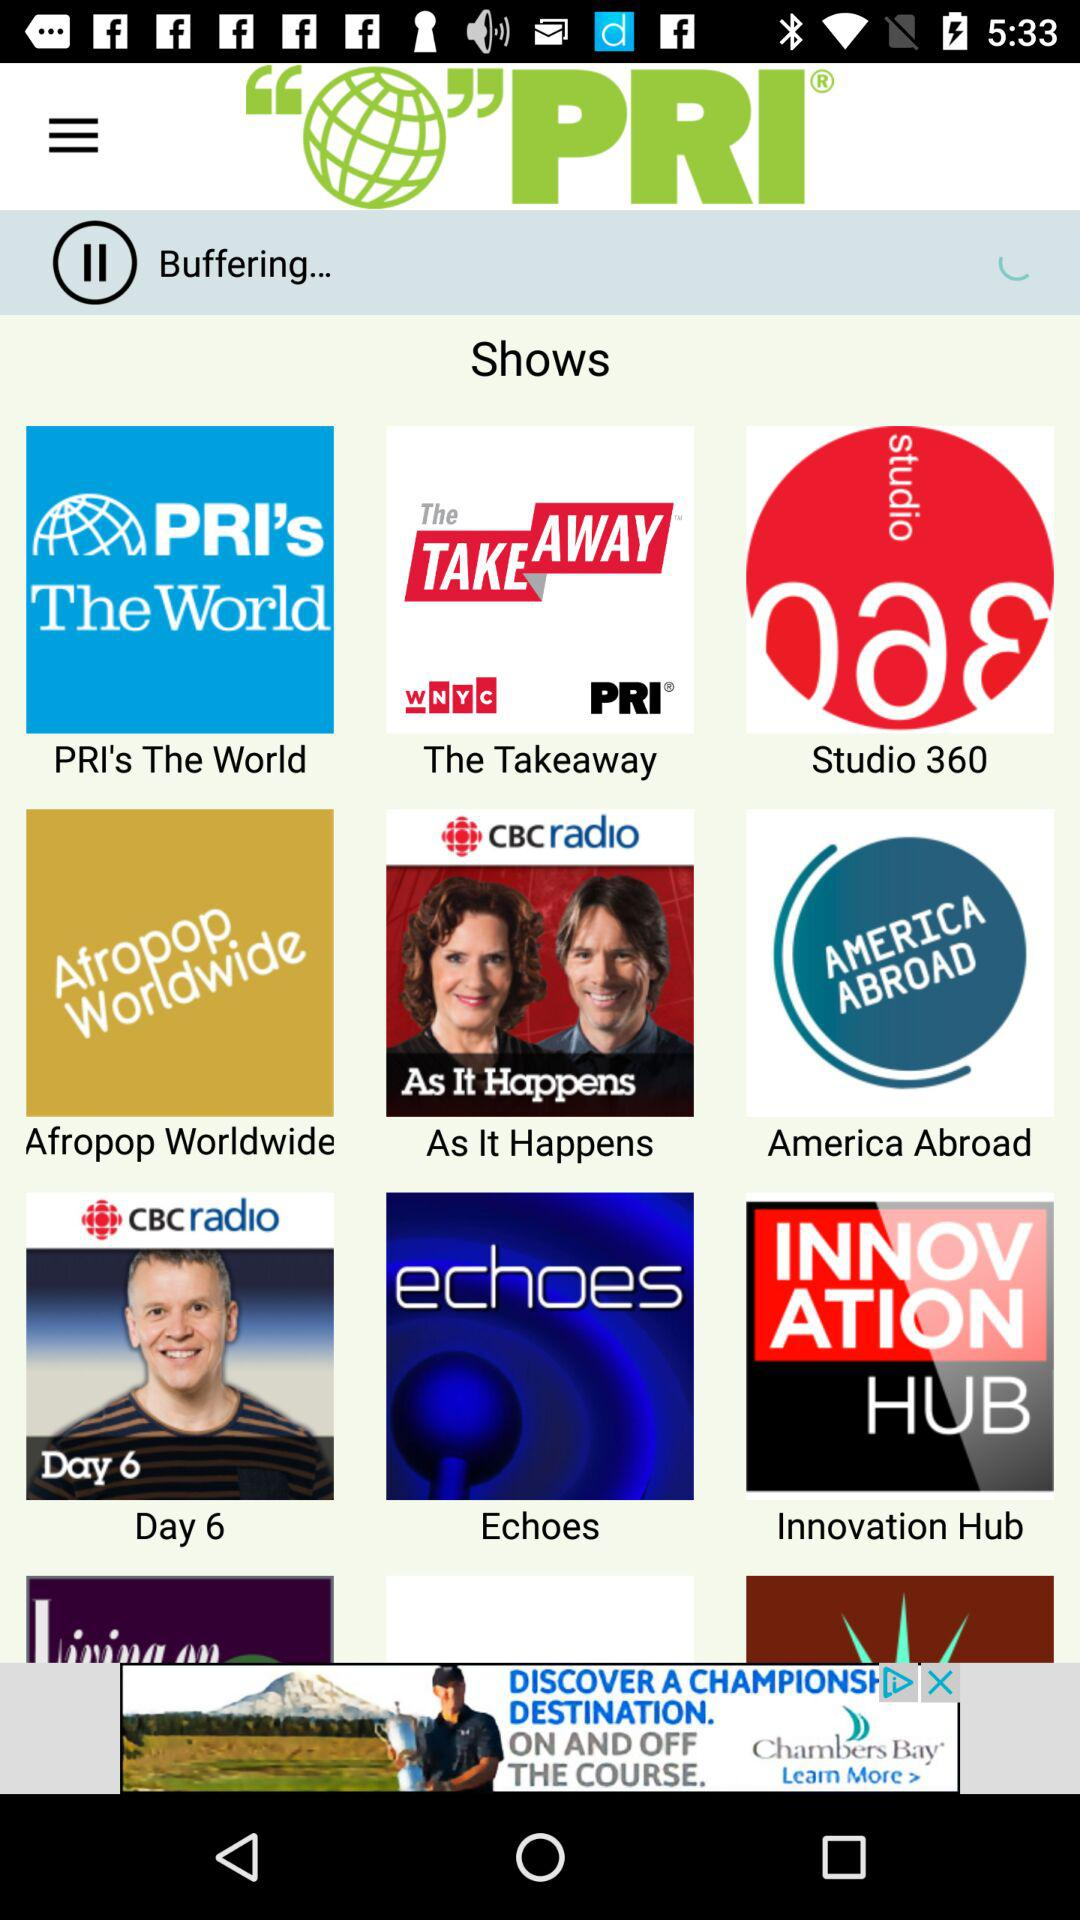What is the application name? The application name is "PRI". 